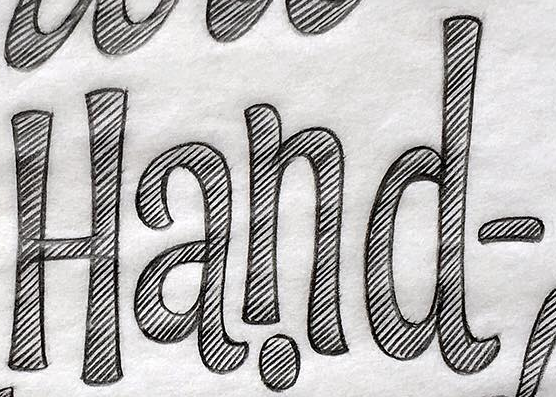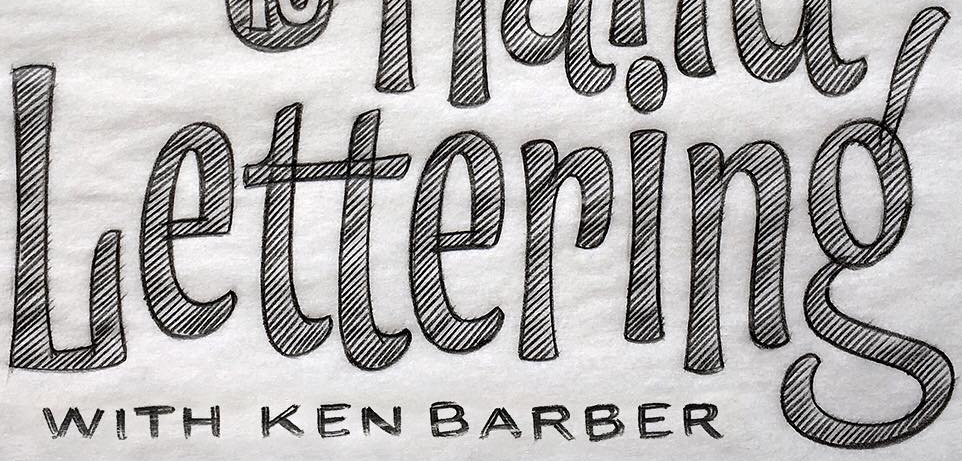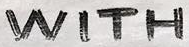What words can you see in these images in sequence, separated by a semicolon? Hand-; Lettering'; WITH 